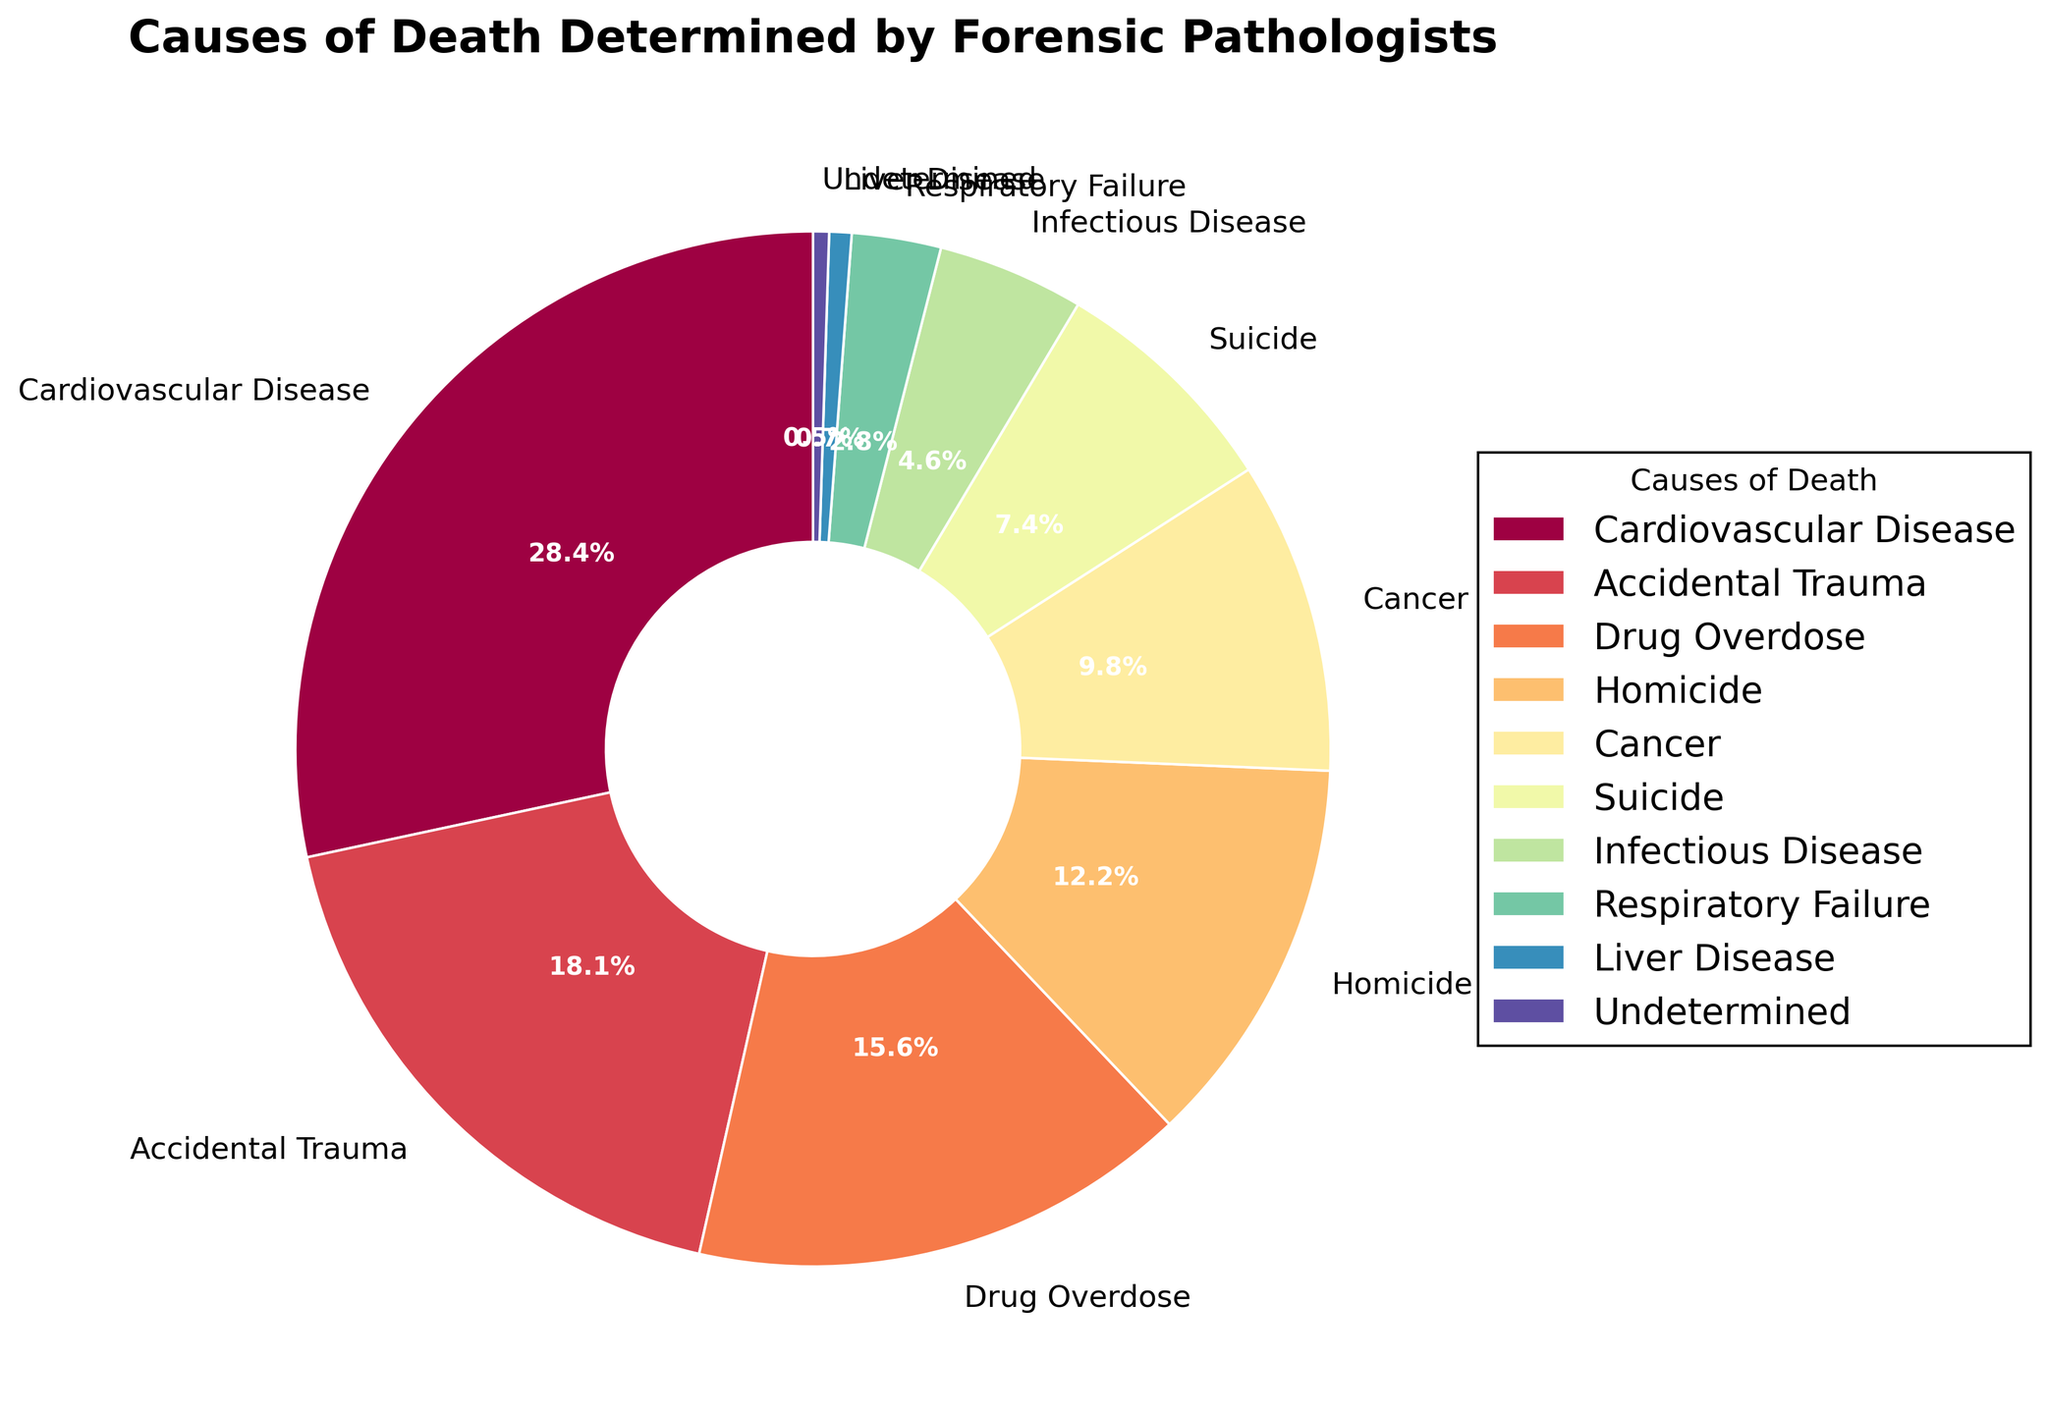Which cause of death has the highest percentage? By examining the pie chart, we can see which slice is the largest or has the highest percentage label. The largest slice corresponds to Cardiovascular Disease.
Answer: Cardiovascular Disease What is the combined percentage of deaths caused by Cardiovascular Disease and Cancer? Sum the individual percentages of Cardiovascular Disease (28.5%) and Cancer (9.8%). Therefore, 28.5% + 9.8% = 38.3%.
Answer: 38.3% Which cause of death has a lower percentage: Suicide or Homicide? By comparing the two slices labeled Suicide (7.4%) and Homicide (12.3%), we can see that 7.4% is lower than 12.3%.
Answer: Suicide What is the total percentage for non-violent causes of death (Cardiovascular Disease, Cancer, Infectious Disease, Respiratory Failure, Liver Disease)? Sum the percentages of these causes of death: 28.5% (Cardiovascular Disease) + 9.8% (Cancer) + 4.6% (Infectious Disease) + 2.8% (Respiratory Failure) + 0.7% (Liver Disease) = 46.4%.
Answer: 46.4% Which cause of death has the smallest percentage, and what is it? The smallest slice in the pie chart is the one labeled Undetermined with 0.5%.
Answer: Undetermined, 0.5% Are there more deaths from Drug Overdose compared to Accidental Trauma, and if so, by what percentage? Compare the percentages: Drug Overdose (15.7%) versus Accidental Trauma (18.2%). Accidental Trauma has a higher percentage.
Answer: No, 2.5% How does the percentage of deaths due to Homicide compare to that due to Infectious Disease? Compare the values directly: Homicide (12.3%) and Infectious Disease (4.6%). Homicide has a higher percentage.
Answer: Higher What is the average percentage of the four leading causes of death (Cardiovascular Disease, Accidental Trauma, Drug Overdose, Homicide)? Sum the percentages of the four causes: 28.5% (Cardiovascular Disease) + 18.2% (Accidental Trauma) + 15.7% (Drug Overdose) + 12.3% (Homicide) = 74.7%, then divide by 4. The average is 74.7% / 4 = 18.675%.
Answer: 18.675% How much larger is the percentage of deaths due to Cardiovascular Disease than that due to Cancer? Subtract Cancer's percentage from Cardiovascular Disease's: 28.5% - 9.8% = 18.7%.
Answer: 18.7% Which causes of death have a percentage less than 5%? Identify the slices with percentages smaller than 5%: Infectious Disease (4.6%), Respiratory Failure (2.8%), Liver Disease (0.7%), and Undetermined (0.5%).
Answer: Infectious Disease, Respiratory Failure, Liver Disease, Undetermined 